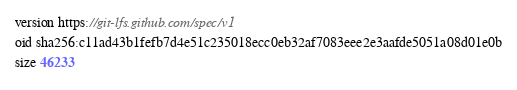Convert code to text. <code><loc_0><loc_0><loc_500><loc_500><_C++_>version https://git-lfs.github.com/spec/v1
oid sha256:c11ad43b1fefb7d4e51c235018ecc0eb32af7083eee2e3aafde5051a08d01e0b
size 46233
</code> 